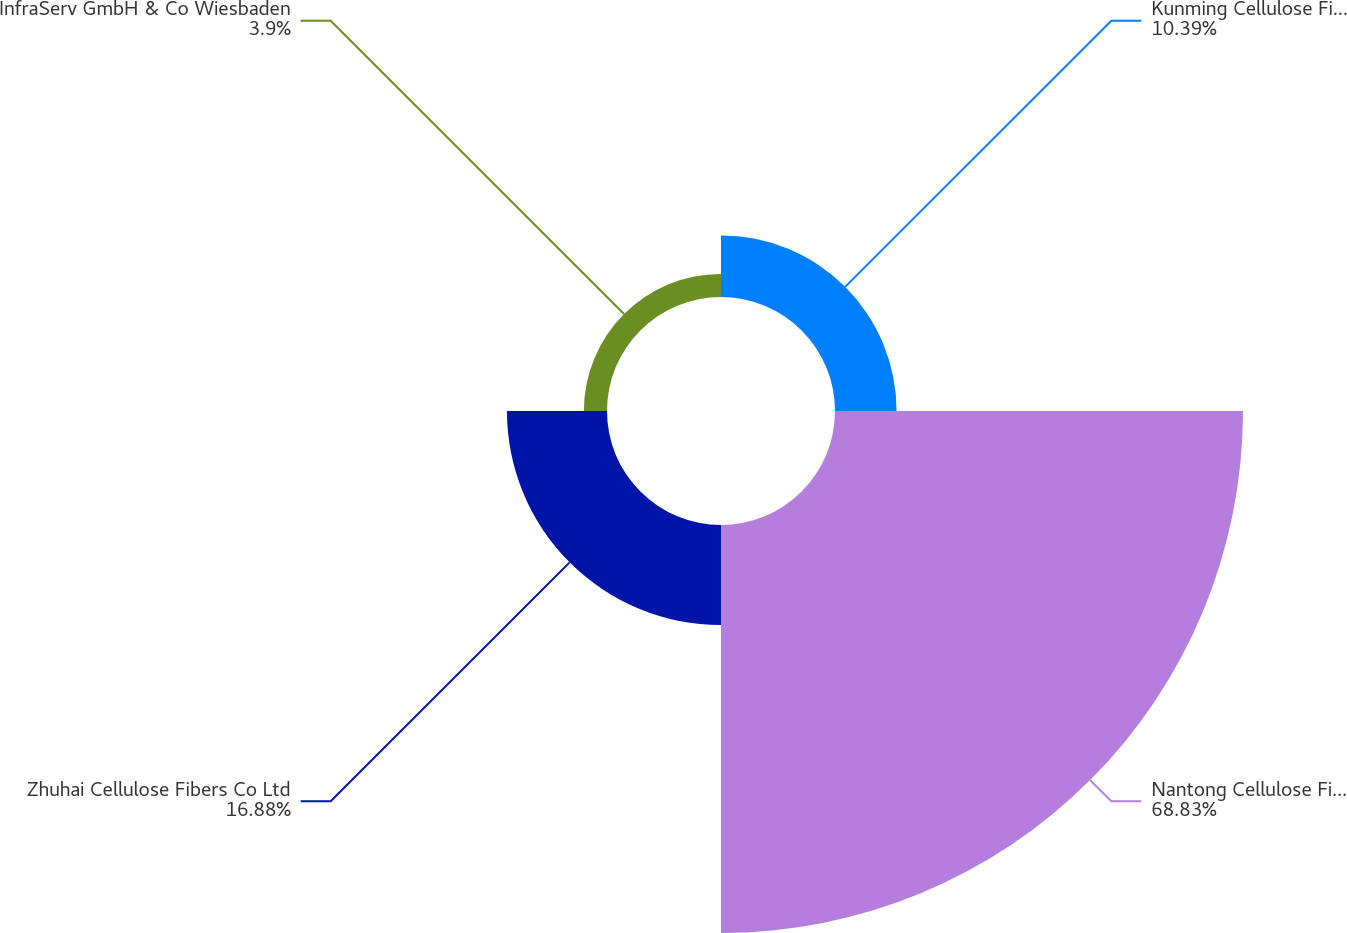<chart> <loc_0><loc_0><loc_500><loc_500><pie_chart><fcel>Kunming Cellulose Fibers Co<fcel>Nantong Cellulose Fibers Co<fcel>Zhuhai Cellulose Fibers Co Ltd<fcel>InfraServ GmbH & Co Wiesbaden<nl><fcel>10.39%<fcel>68.83%<fcel>16.88%<fcel>3.9%<nl></chart> 